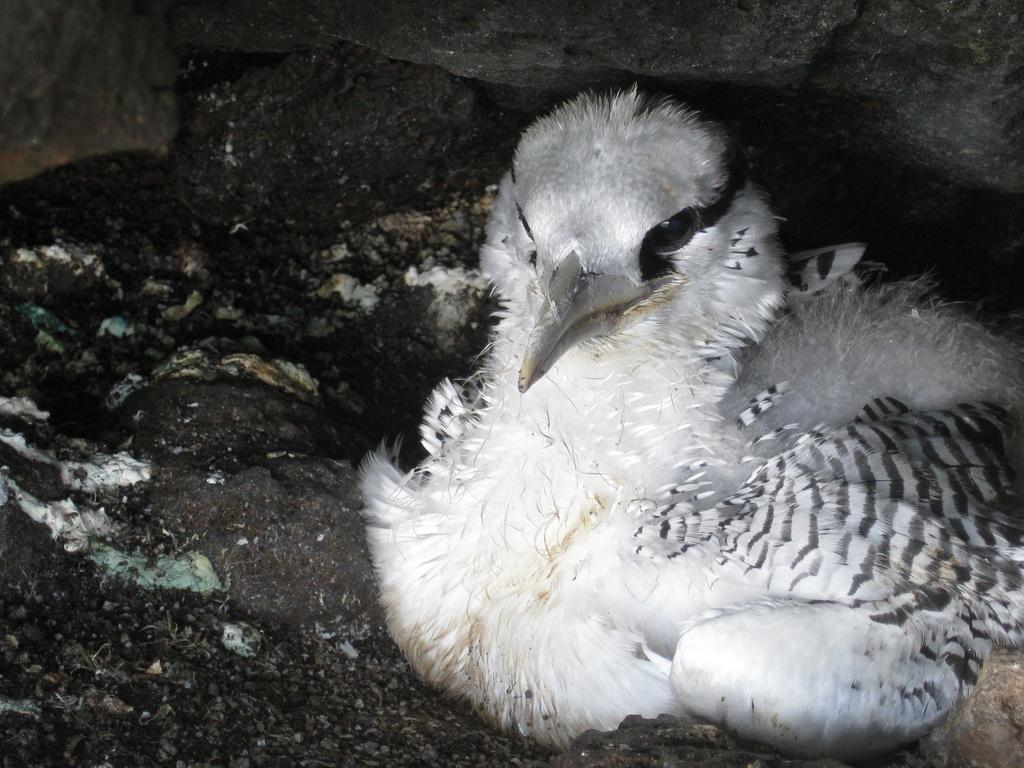Can you describe this image briefly? In this image there is a bird sitting on the surface, beneath the rock. 